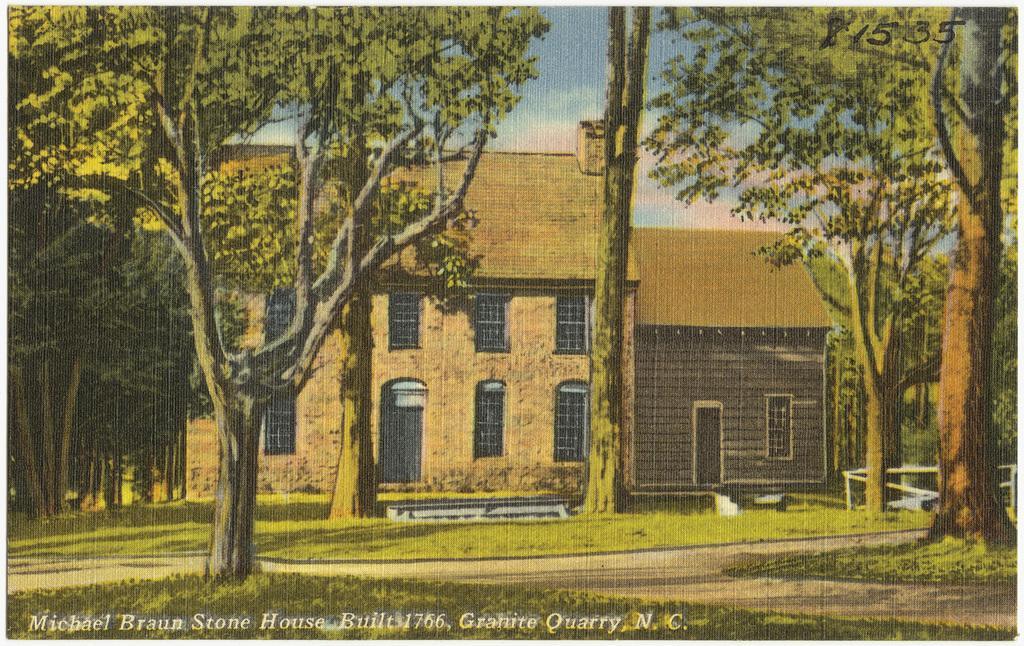How would you summarize this image in a sentence or two? This image consists of a poster. In which there is a house along with windows. In the front, there are trees. At the bottom, there is a grass. At the top, there is sky. 